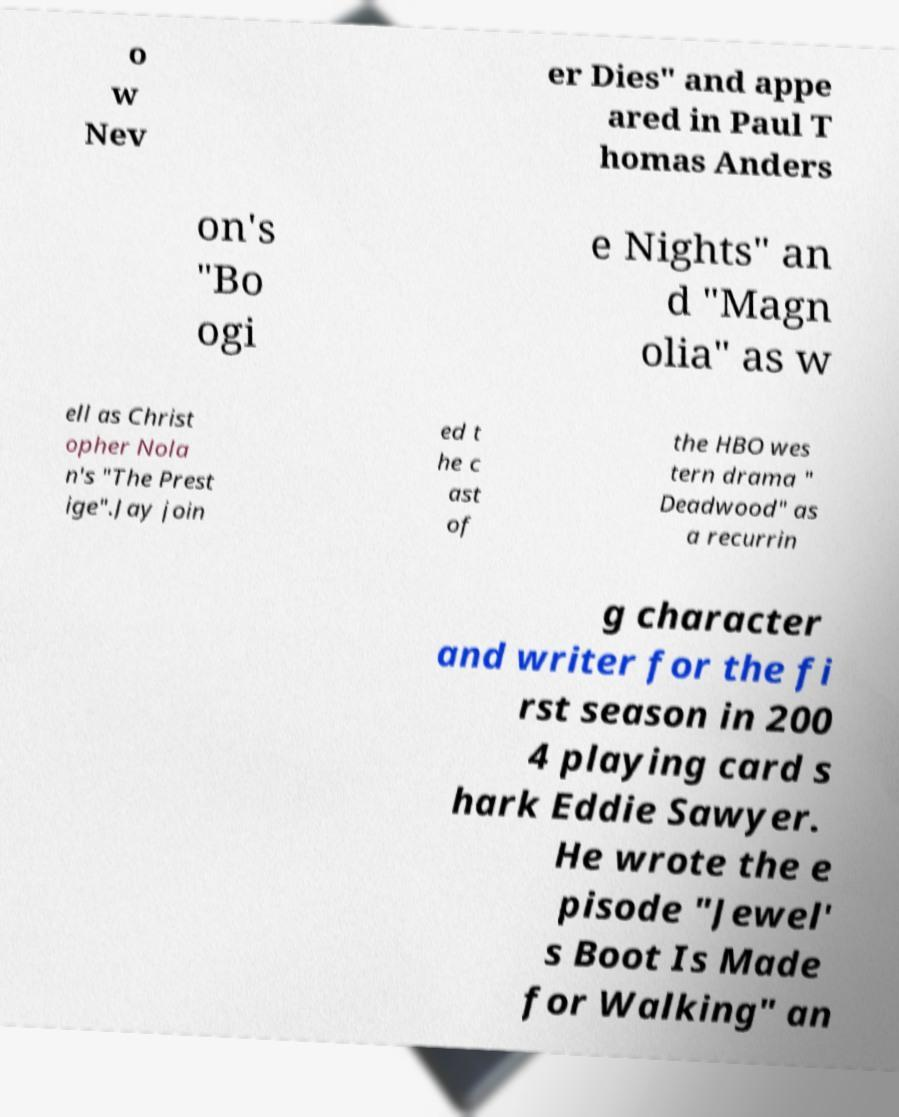Please read and relay the text visible in this image. What does it say? o w Nev er Dies" and appe ared in Paul T homas Anders on's "Bo ogi e Nights" an d "Magn olia" as w ell as Christ opher Nola n's "The Prest ige".Jay join ed t he c ast of the HBO wes tern drama " Deadwood" as a recurrin g character and writer for the fi rst season in 200 4 playing card s hark Eddie Sawyer. He wrote the e pisode "Jewel' s Boot Is Made for Walking" an 